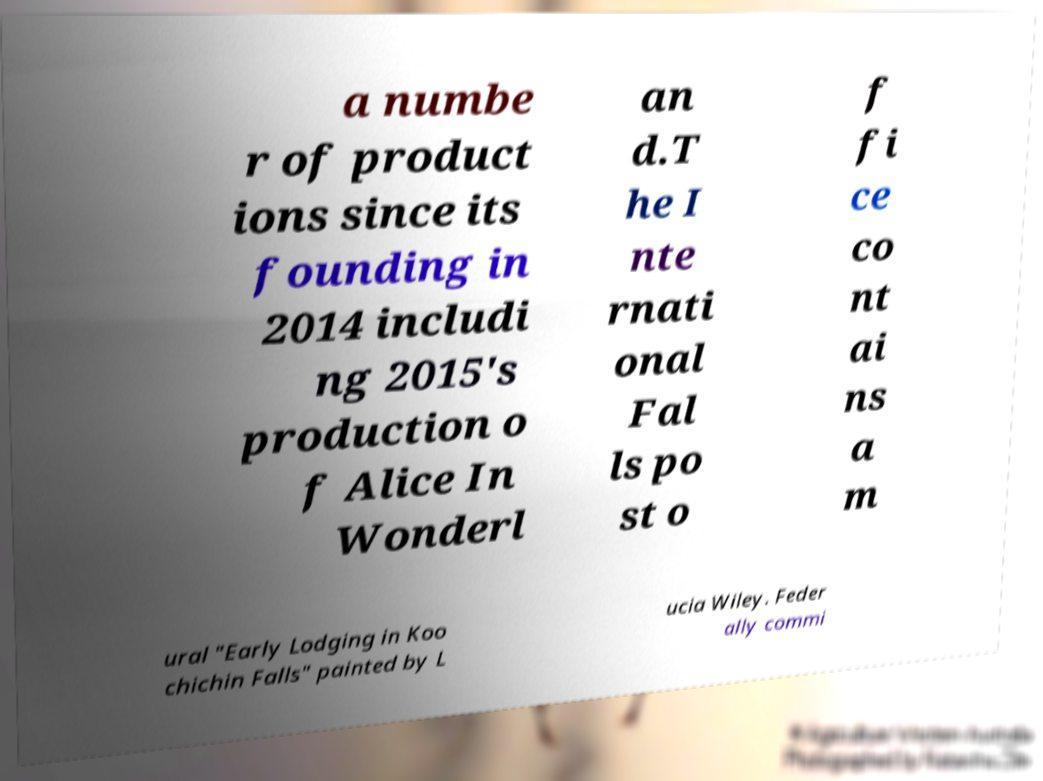Can you accurately transcribe the text from the provided image for me? a numbe r of product ions since its founding in 2014 includi ng 2015's production o f Alice In Wonderl an d.T he I nte rnati onal Fal ls po st o f fi ce co nt ai ns a m ural "Early Lodging in Koo chichin Falls" painted by L ucia Wiley. Feder ally commi 